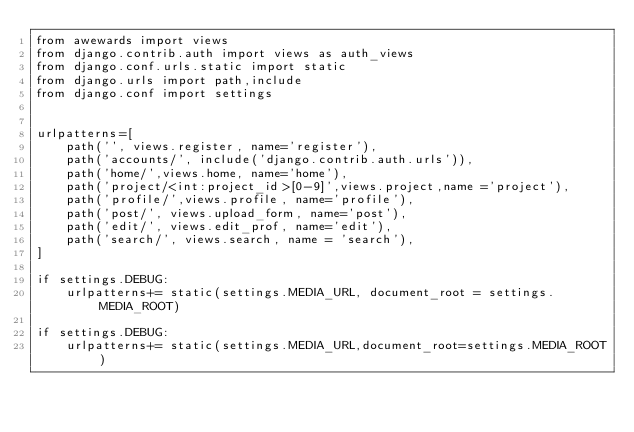Convert code to text. <code><loc_0><loc_0><loc_500><loc_500><_Python_>from awewards import views
from django.contrib.auth import views as auth_views
from django.conf.urls.static import static
from django.urls import path,include
from django.conf import settings


urlpatterns=[
    path('', views.register, name='register'),
    path('accounts/', include('django.contrib.auth.urls')),
    path('home/',views.home, name='home'),
    path('project/<int:project_id>[0-9]',views.project,name ='project'),
    path('profile/',views.profile, name='profile'),
    path('post/', views.upload_form, name='post'),
    path('edit/', views.edit_prof, name='edit'),
    path('search/', views.search, name = 'search'),
]

if settings.DEBUG:
    urlpatterns+= static(settings.MEDIA_URL, document_root = settings.MEDIA_ROOT)

if settings.DEBUG:
    urlpatterns+= static(settings.MEDIA_URL,document_root=settings.MEDIA_ROOT)</code> 